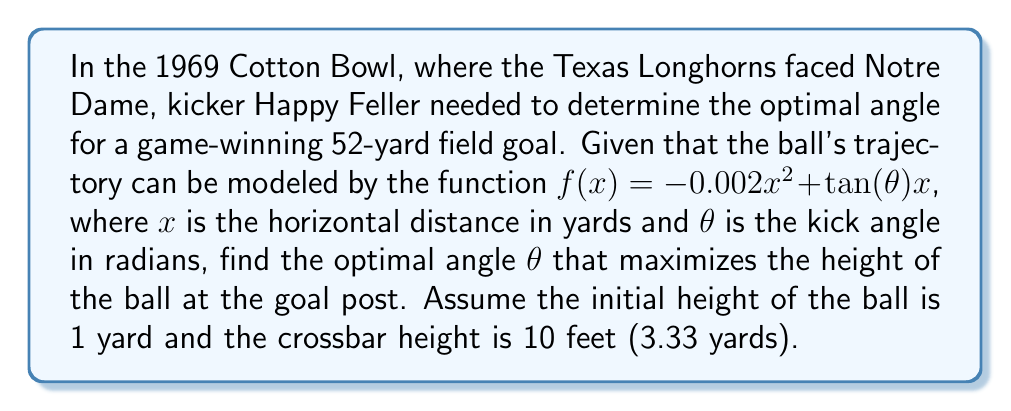Could you help me with this problem? To solve this problem, we'll use nonlinear optimization techniques:

1) The height of the ball at the goal post (52 yards away) is given by:
   $f(52) = -0.002(52)^2 + 52\tan(\theta) + 1$

2) We want to maximize this function with respect to $\theta$. To do this, we'll take the derivative and set it equal to zero:
   $\frac{d}{d\theta}f(52) = 52\sec^2(\theta) = 0$

3) However, $\sec^2(\theta)$ is always positive, so this equation has no solution. This means the maximum must occur at the boundaries of our feasible region.

4) The lower bound is when the ball just clears the crossbar:
   $-0.002(52)^2 + 52\tan(\theta) + 1 = 3.33$
   $52\tan(\theta) = 7.7744$
   $\theta = \arctan(0.1495) \approx 0.1485$ radians

5) The upper bound is 90 degrees ($\frac{\pi}{2}$ radians), but this is impractical for kicking.

6) Therefore, the optimal angle is the lower bound, which gives the minimum angle needed to clear the crossbar.

7) Converting to degrees: $\theta \approx 0.1485 \times \frac{180}{\pi} \approx 8.51°$
Answer: $\theta \approx 8.51°$ 